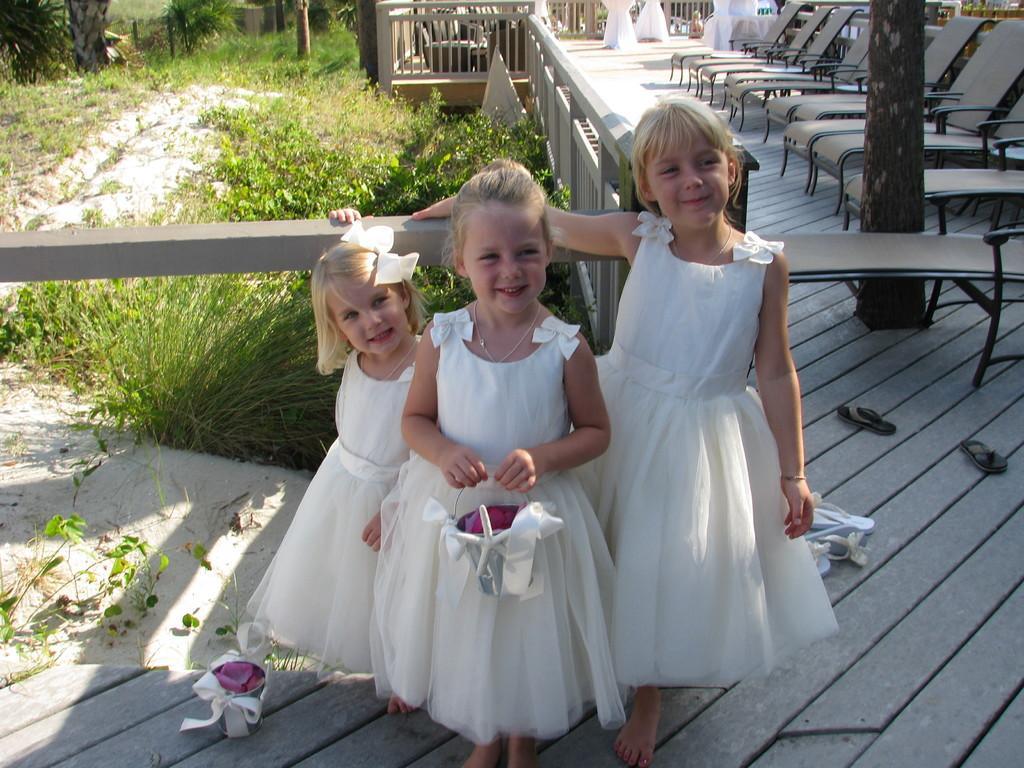Could you give a brief overview of what you see in this image? In this image, we can see three persons wearing clothes and standing in front of plants. There is a kid in the middle of the image holding a bucket with her hands. There are some chair in the top right of the image. 